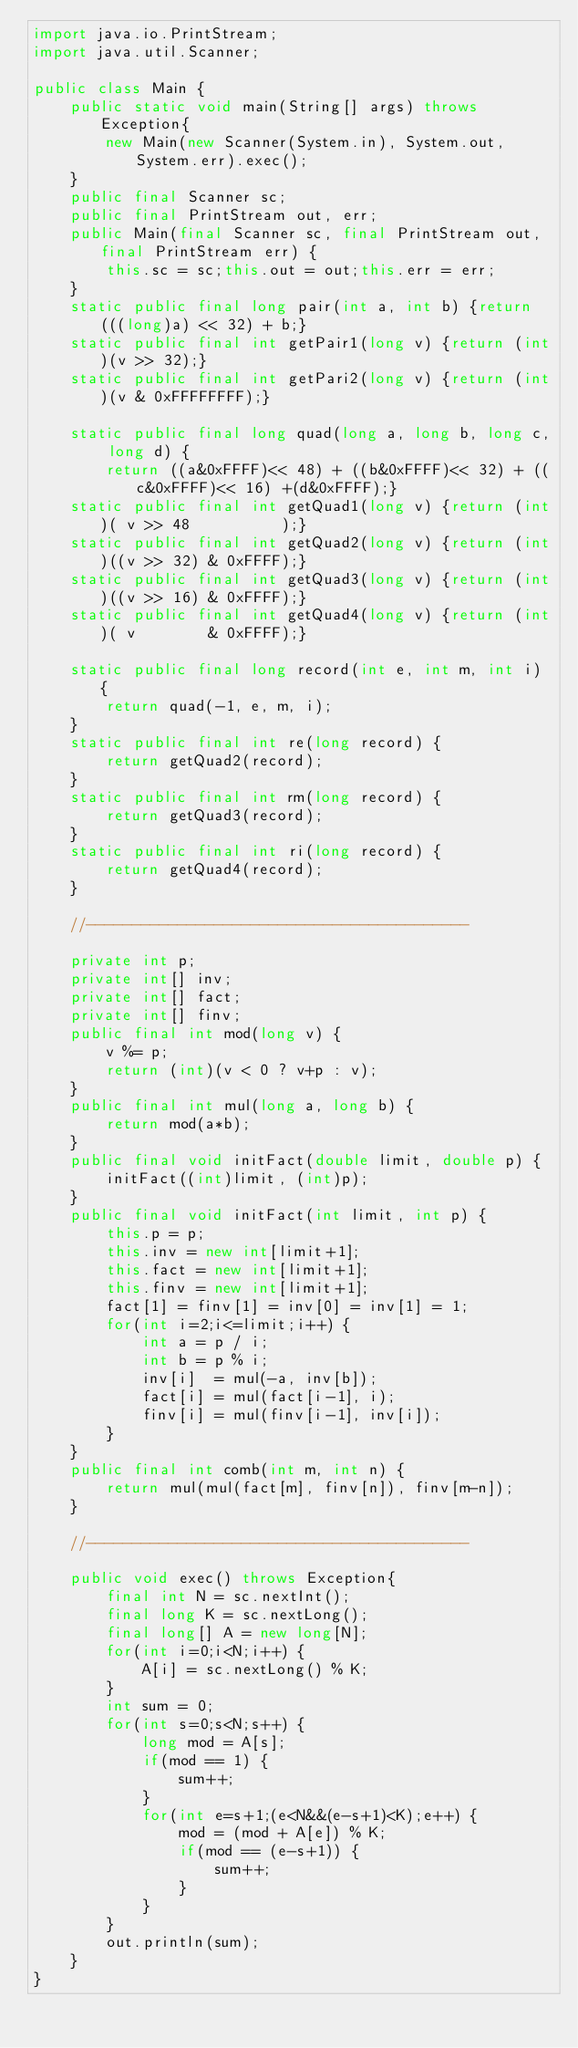<code> <loc_0><loc_0><loc_500><loc_500><_Java_>import java.io.PrintStream;
import java.util.Scanner;

public class Main {
	public static void main(String[] args) throws Exception{
		new Main(new Scanner(System.in), System.out, System.err).exec();
	}
	public final Scanner sc;
	public final PrintStream out, err;
	public Main(final Scanner sc, final PrintStream out, final PrintStream err) {
		this.sc = sc;this.out = out;this.err = err;
	}
	static public final long pair(int a, int b) {return (((long)a) << 32) + b;}
	static public final int getPair1(long v) {return (int)(v >> 32);}
	static public final int getPari2(long v) {return (int)(v & 0xFFFFFFFF);}

	static public final long quad(long a, long b, long c, long d) {
		return ((a&0xFFFF)<< 48) + ((b&0xFFFF)<< 32) + ((c&0xFFFF)<< 16) +(d&0xFFFF);}
	static public final int getQuad1(long v) {return (int)( v >> 48          );}
	static public final int getQuad2(long v) {return (int)((v >> 32) & 0xFFFF);}
	static public final int getQuad3(long v) {return (int)((v >> 16) & 0xFFFF);}
	static public final int getQuad4(long v) {return (int)( v        & 0xFFFF);}

	static public final long record(int e, int m, int i) {
		return quad(-1, e, m, i);
	}
	static public final int re(long record) {
		return getQuad2(record);
	}
	static public final int rm(long record) {
		return getQuad3(record);
	}
	static public final int ri(long record) {
		return getQuad4(record);
	}

	//------------------------------------------

	private int p;
	private int[] inv;
	private int[] fact;
	private int[] finv;
	public final int mod(long v) {
		v %= p;
		return (int)(v < 0 ? v+p : v);
	}
	public final int mul(long a, long b) {
		return mod(a*b);
	}
	public final void initFact(double limit, double p) {
		initFact((int)limit, (int)p);
	}
	public final void initFact(int limit, int p) {
		this.p = p;
		this.inv = new int[limit+1];
		this.fact = new int[limit+1];
		this.finv = new int[limit+1];
		fact[1] = finv[1] = inv[0] = inv[1] = 1;
		for(int i=2;i<=limit;i++) {
			int a = p / i;
			int b = p % i;
			inv[i]  = mul(-a, inv[b]);
			fact[i] = mul(fact[i-1], i);
			finv[i] = mul(finv[i-1], inv[i]);
		}
	}
	public final int comb(int m, int n) {
		return mul(mul(fact[m], finv[n]), finv[m-n]);
	}

	//------------------------------------------

	public void exec() throws Exception{
		final int N = sc.nextInt();
		final long K = sc.nextLong();
		final long[] A = new long[N];
		for(int i=0;i<N;i++) {
			A[i] = sc.nextLong() % K;
		}
		int sum = 0;
		for(int s=0;s<N;s++) {
			long mod = A[s];
			if(mod == 1) {
				sum++;
			}
			for(int e=s+1;(e<N&&(e-s+1)<K);e++) {
				mod = (mod + A[e]) % K;
				if(mod == (e-s+1)) {
					sum++;
				}
			}
		}
		out.println(sum);
	}
}
</code> 